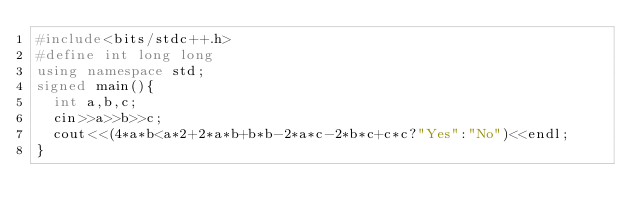<code> <loc_0><loc_0><loc_500><loc_500><_C++_>#include<bits/stdc++.h>
#define int long long
using namespace std;
signed main(){
  int a,b,c;
  cin>>a>>b>>c;
  cout<<(4*a*b<a*2+2*a*b+b*b-2*a*c-2*b*c+c*c?"Yes":"No")<<endl;
}</code> 